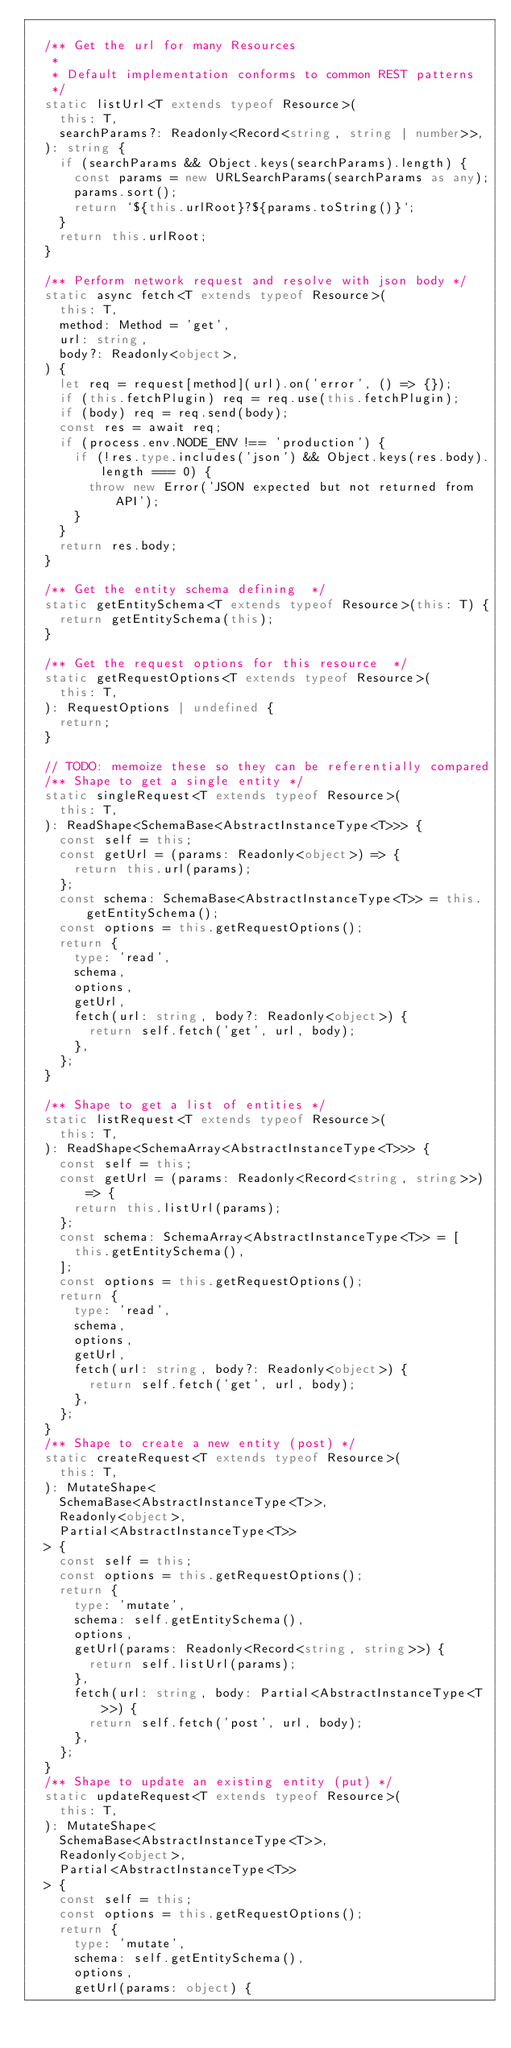Convert code to text. <code><loc_0><loc_0><loc_500><loc_500><_TypeScript_>
  /** Get the url for many Resources
   *
   * Default implementation conforms to common REST patterns
   */
  static listUrl<T extends typeof Resource>(
    this: T,
    searchParams?: Readonly<Record<string, string | number>>,
  ): string {
    if (searchParams && Object.keys(searchParams).length) {
      const params = new URLSearchParams(searchParams as any);
      params.sort();
      return `${this.urlRoot}?${params.toString()}`;
    }
    return this.urlRoot;
  }

  /** Perform network request and resolve with json body */
  static async fetch<T extends typeof Resource>(
    this: T,
    method: Method = 'get',
    url: string,
    body?: Readonly<object>,
  ) {
    let req = request[method](url).on('error', () => {});
    if (this.fetchPlugin) req = req.use(this.fetchPlugin);
    if (body) req = req.send(body);
    const res = await req;
    if (process.env.NODE_ENV !== 'production') {
      if (!res.type.includes('json') && Object.keys(res.body).length === 0) {
        throw new Error('JSON expected but not returned from API');
      }
    }
    return res.body;
  }

  /** Get the entity schema defining  */
  static getEntitySchema<T extends typeof Resource>(this: T) {
    return getEntitySchema(this);
  }

  /** Get the request options for this resource  */
  static getRequestOptions<T extends typeof Resource>(
    this: T,
  ): RequestOptions | undefined {
    return;
  }

  // TODO: memoize these so they can be referentially compared
  /** Shape to get a single entity */
  static singleRequest<T extends typeof Resource>(
    this: T,
  ): ReadShape<SchemaBase<AbstractInstanceType<T>>> {
    const self = this;
    const getUrl = (params: Readonly<object>) => {
      return this.url(params);
    };
    const schema: SchemaBase<AbstractInstanceType<T>> = this.getEntitySchema();
    const options = this.getRequestOptions();
    return {
      type: 'read',
      schema,
      options,
      getUrl,
      fetch(url: string, body?: Readonly<object>) {
        return self.fetch('get', url, body);
      },
    };
  }

  /** Shape to get a list of entities */
  static listRequest<T extends typeof Resource>(
    this: T,
  ): ReadShape<SchemaArray<AbstractInstanceType<T>>> {
    const self = this;
    const getUrl = (params: Readonly<Record<string, string>>) => {
      return this.listUrl(params);
    };
    const schema: SchemaArray<AbstractInstanceType<T>> = [
      this.getEntitySchema(),
    ];
    const options = this.getRequestOptions();
    return {
      type: 'read',
      schema,
      options,
      getUrl,
      fetch(url: string, body?: Readonly<object>) {
        return self.fetch('get', url, body);
      },
    };
  }
  /** Shape to create a new entity (post) */
  static createRequest<T extends typeof Resource>(
    this: T,
  ): MutateShape<
    SchemaBase<AbstractInstanceType<T>>,
    Readonly<object>,
    Partial<AbstractInstanceType<T>>
  > {
    const self = this;
    const options = this.getRequestOptions();
    return {
      type: 'mutate',
      schema: self.getEntitySchema(),
      options,
      getUrl(params: Readonly<Record<string, string>>) {
        return self.listUrl(params);
      },
      fetch(url: string, body: Partial<AbstractInstanceType<T>>) {
        return self.fetch('post', url, body);
      },
    };
  }
  /** Shape to update an existing entity (put) */
  static updateRequest<T extends typeof Resource>(
    this: T,
  ): MutateShape<
    SchemaBase<AbstractInstanceType<T>>,
    Readonly<object>,
    Partial<AbstractInstanceType<T>>
  > {
    const self = this;
    const options = this.getRequestOptions();
    return {
      type: 'mutate',
      schema: self.getEntitySchema(),
      options,
      getUrl(params: object) {</code> 